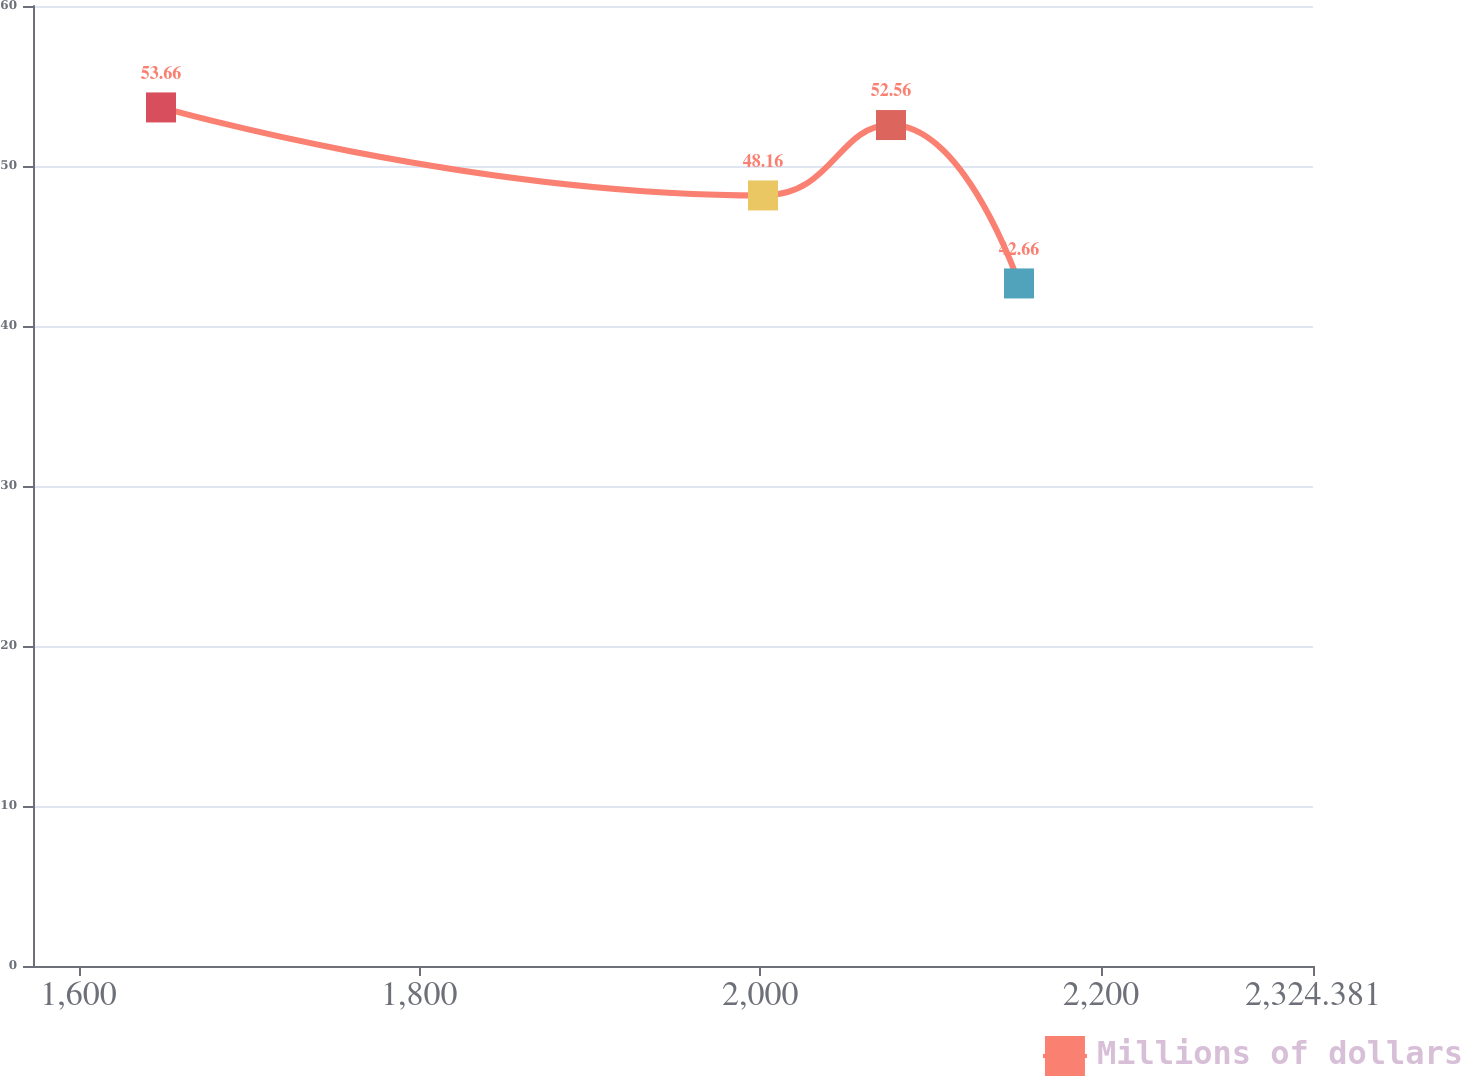<chart> <loc_0><loc_0><loc_500><loc_500><line_chart><ecel><fcel>Millions of dollars<nl><fcel>1648.4<fcel>53.66<nl><fcel>2001.64<fcel>48.16<nl><fcel>2076.75<fcel>52.56<nl><fcel>2151.86<fcel>42.66<nl><fcel>2399.49<fcel>49.42<nl></chart> 